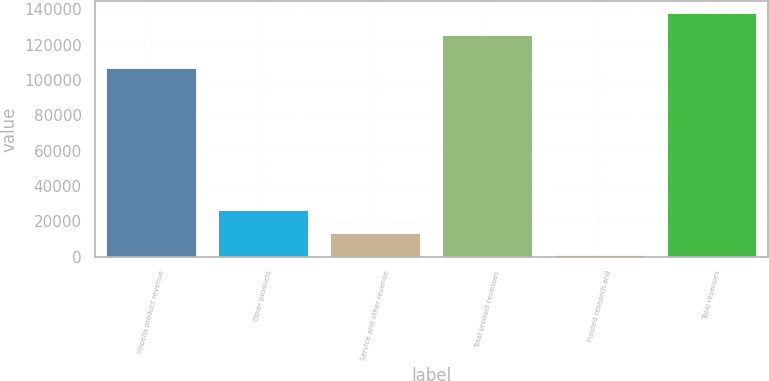Convert chart to OTSL. <chart><loc_0><loc_0><loc_500><loc_500><bar_chart><fcel>Impella product revenue<fcel>Other products<fcel>Service and other revenue<fcel>Total product revenues<fcel>Funded research and<fcel>Total revenues<nl><fcel>106925<fcel>26146.2<fcel>13617.6<fcel>125286<fcel>1089<fcel>137815<nl></chart> 